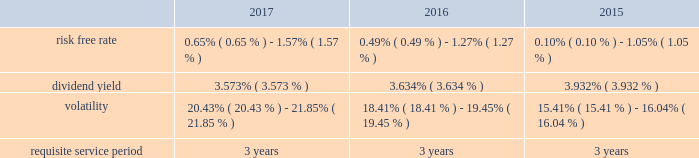Performance based restricted stock awards is generally recognized using the accelerated amortization method with each vesting tranche valued as a separate award , with a separate vesting date , consistent with the estimated value of the award at each period end .
Additionally , compensation expense is adjusted for actual forfeitures for all awards in the period that the award was forfeited .
Compensation expense for stock options is generally recognized on a straight-line basis over the requisite service period .
Maa presents stock compensation expense in the consolidated statements of operations in "general and administrative expenses" .
Effective january 1 , 2017 , the company adopted asu 2016-09 , improvements to employee share- based payment accounting , which allows employers to make a policy election to account for forfeitures as they occur .
The company elected this option using the modified retrospective transition method , with a cumulative effect adjustment to retained earnings , and there was no material effect on the consolidated financial position or results of operations taken as a whole resulting from the reversal of previously estimated forfeitures .
Total compensation expense under the stock plan was approximately $ 10.8 million , $ 12.2 million and $ 6.9 million for the years ended december 31 , 2017 , 2016 and 2015 , respectively .
Of these amounts , total compensation expense capitalized was approximately $ 0.2 million , $ 0.7 million and $ 0.7 million for the years ended december 31 , 2017 , 2016 and 2015 , respectively .
As of december 31 , 2017 , the total unrecognized compensation expense was approximately $ 14.1 million .
This cost is expected to be recognized over the remaining weighted average period of 1.2 years .
Total cash paid for the settlement of plan shares totaled $ 4.8 million , $ 2.0 million and $ 1.0 million for the years ended december 31 , 2017 , 2016 and 2015 , respectively .
Information concerning grants under the stock plan is listed below .
Restricted stock in general , restricted stock is earned based on either a service condition , performance condition , or market condition , or a combination thereof , and generally vests ratably over a period from 1 year to 5 years .
Service based awards are earned when the employee remains employed over the requisite service period and are valued on the grant date based upon the market price of maa common stock on the date of grant .
Market based awards are earned when maa reaches a specified stock price or specified return on the stock price ( price appreciation plus dividends ) and are valued on the grant date using a monte carlo simulation .
Performance based awards are earned when maa reaches certain operational goals such as funds from operations , or ffo , targets and are valued based upon the market price of maa common stock on the date of grant as well as the probability of reaching the stated targets .
Maa remeasures the fair value of the performance based awards each balance sheet date with adjustments made on a cumulative basis until the award is settled and the final compensation is known .
The weighted average grant date fair value per share of restricted stock awards granted during the years ended december 31 , 2017 , 2016 and 2015 , was $ 84.53 , $ 73.20 and $ 68.35 , respectively .
The following is a summary of the key assumptions used in the valuation calculations for market based awards granted during the years ended december 31 , 2017 , 2016 and 2015: .
The risk free rate was based on a zero coupon risk-free rate .
The minimum risk free rate was based on a period of 0.25 years for the years ended december 31 , 2017 , 2016 and 2015 .
The maximum risk free rate was based on a period of 3 years for the years ended december 31 , 2017 , 2016 and 2015 .
The dividend yield was based on the closing stock price of maa stock on the date of grant .
Volatility for maa was obtained by using a blend of both historical and implied volatility calculations .
Historical volatility was based on the standard deviation of daily total continuous returns , and implied volatility was based on the trailing month average of daily implied volatilities interpolating between the volatilities implied by stock call option contracts that were closest to the terms shown and closest to the money .
The minimum volatility was based on a period of 3 years , 2 years and 1 year for the years ended december 31 , 2017 , 2016 and 2015 , respectively .
The maximum volatility was based on a period of 1 year , 1 year and 2 years for the years ended december 31 , 2017 , 2016 and 2015 , respectively .
The requisite service period is based on the criteria for the separate programs according to the vesting schedule. .
What was the percent of the change in the weighted average grant date fair value per share of restricted stock from 2016 to 2017? 
Rationale: the weighted average grant date fair value per share of restricted stock increased by 15.5% from 2016 to 2017
Computations: ((84.53 - 73.20) / 73.20)
Answer: 0.15478. 